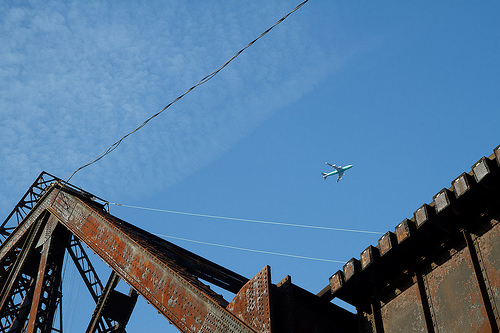Please provide the bounding box coordinate of the region this sentence describes: white clouds in blue sky. [0.56, 0.24, 0.61, 0.32] - Some fluffy white clouds are present in this blue sky area. 